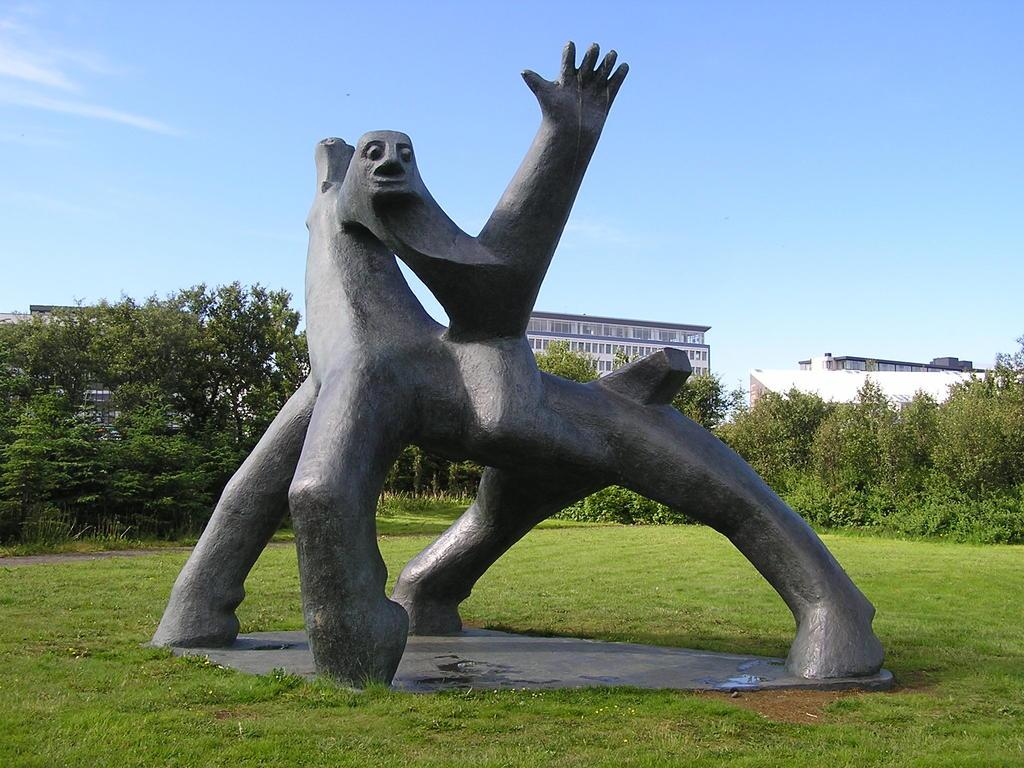What is located on the ground in the image? There is a statue on the ground in the image. What can be seen in the background of the image? There are trees, buildings, and the sky visible in the background of the image. What direction is the goose facing in the image? There is no goose present in the image, so it is not possible to determine the direction it might be facing. 